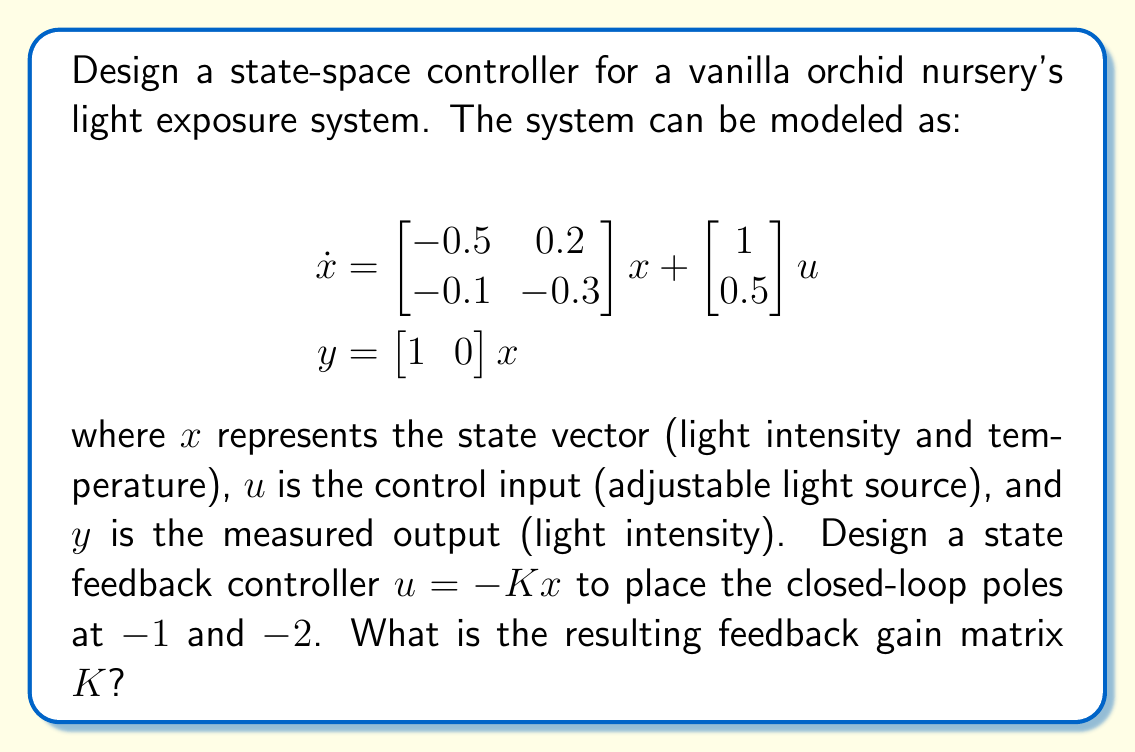What is the answer to this math problem? To design the state feedback controller, we'll follow these steps:

1) First, we need to determine the characteristic equation of the closed-loop system. The closed-loop system is given by:

   $$\dot{x} = (A - BK)x$$

   where $A = \begin{bmatrix} -0.5 & 0.2 \\ -0.1 & -0.3 \end{bmatrix}$ and $B = \begin{bmatrix} 1 \\ 0.5 \end{bmatrix}$

2) The characteristic equation is:

   $$\det(sI - (A - BK)) = 0$$

3) Let $K = \begin{bmatrix} k_1 & k_2 \end{bmatrix}$. Expanding the determinant:

   $$\begin{vmatrix} 
   s + 0.5 + k_1 & -0.2 + k_2 \\
   0.1 + 0.5k_1 & s + 0.3 + 0.5k_2
   \end{vmatrix} = 0$$

4) This gives us:

   $$(s + 0.5 + k_1)(s + 0.3 + 0.5k_2) - (-0.2 + k_2)(0.1 + 0.5k_1) = 0$$

5) Expanding:

   $$s^2 + (0.8 + k_1 + 0.5k_2)s + (0.15 + 0.5k_1 + 0.3k_2 + 0.5k_1k_2) + (0.02 - 0.1k_2 - 0.5k_1k_2) = 0$$

6) Simplifying:

   $$s^2 + (0.8 + k_1 + 0.5k_2)s + (0.17 + 0.5k_1 + 0.2k_2) = 0$$

7) We want the closed-loop poles at $-1$ and $-2$, so our desired characteristic equation is:

   $$(s + 1)(s + 2) = s^2 + 3s + 2 = 0$$

8) Comparing coefficients:

   $$0.8 + k_1 + 0.5k_2 = 3$$
   $$0.17 + 0.5k_1 + 0.2k_2 = 2$$

9) Solving these equations:

   $$k_1 = 2.2 - 0.5k_2$$
   $$0.17 + 0.5(2.2 - 0.5k_2) + 0.2k_2 = 2$$
   $$1.27 - 0.25k_2 + 0.2k_2 = 2$$
   $$-0.05k_2 = 0.73$$
   $$k_2 = -14.6$$

10) Substituting back:

    $$k_1 = 2.2 - 0.5(-14.6) = 9.5$$

Therefore, the feedback gain matrix $K$ is $\begin{bmatrix} 9.5 & -14.6 \end{bmatrix}$.
Answer: $K = \begin{bmatrix} 9.5 & -14.6 \end{bmatrix}$ 